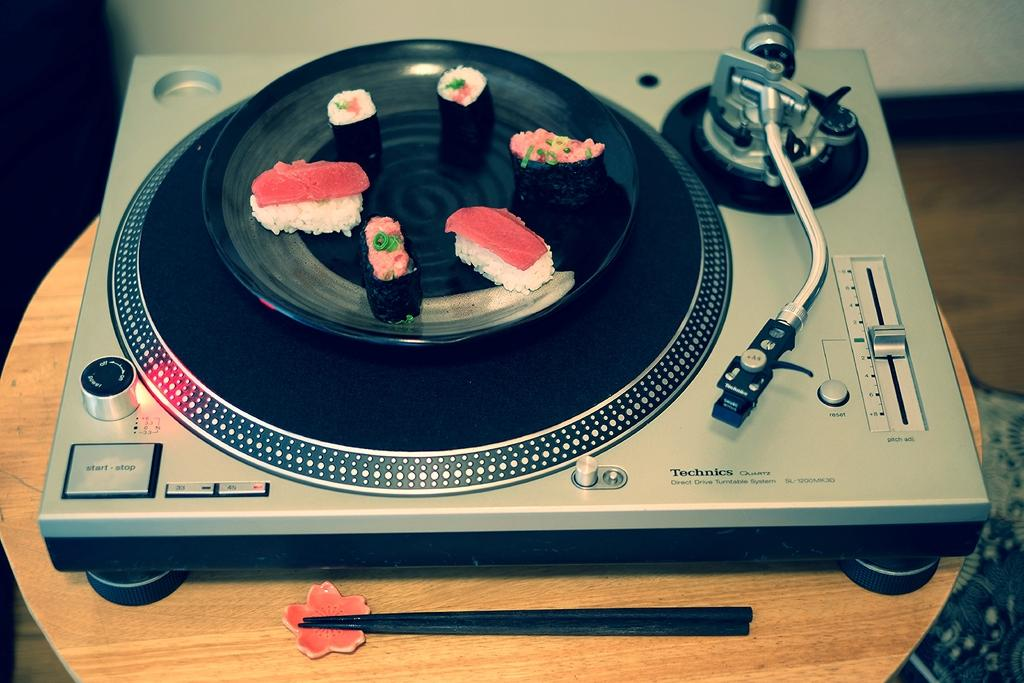What device is the main subject of the image? There is a portable Gamma-phone in the image. Where is the Gamma-phone placed in the image? The Gamma-phone is placed on a wooden table top. What else can be seen on the table top? There is a black color plate on the table top. What type of food is on the plate? Some chocolate pastry is visible on the plate. What type of crime is being committed in the image? There is no crime being committed in the image; it features a Gamma-phone, a table top, a black color plate, and chocolate pastry. How many bridges are visible in the image? There are no bridges visible in the image. 